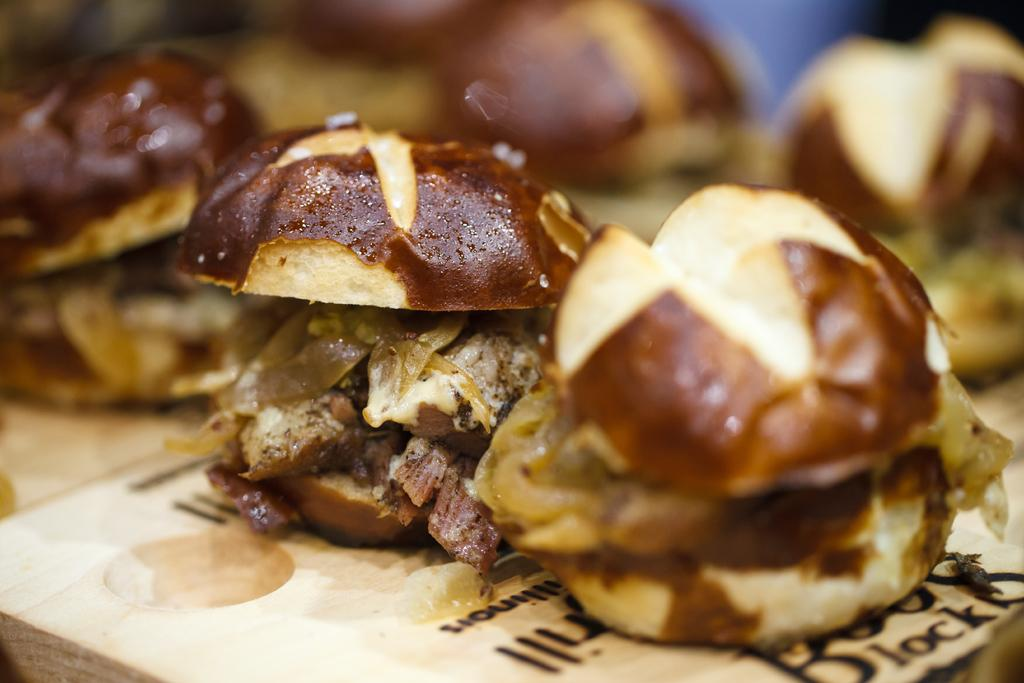What type of food can be seen in the foreground of the image? There are burgers in the foreground of the image. What object is located at the bottom of the image? There is an object that looks like a plate at the bottom of the image. Can you describe the background of the image? The background of the image is blurry. What is the name of the daughter who is helping to wash the burgers in the image? There is no daughter or washing activity present in the image; it features burgers and a plate. What type of battle is depicted in the background of the image? There is no battle present in the image; the background is blurry. 